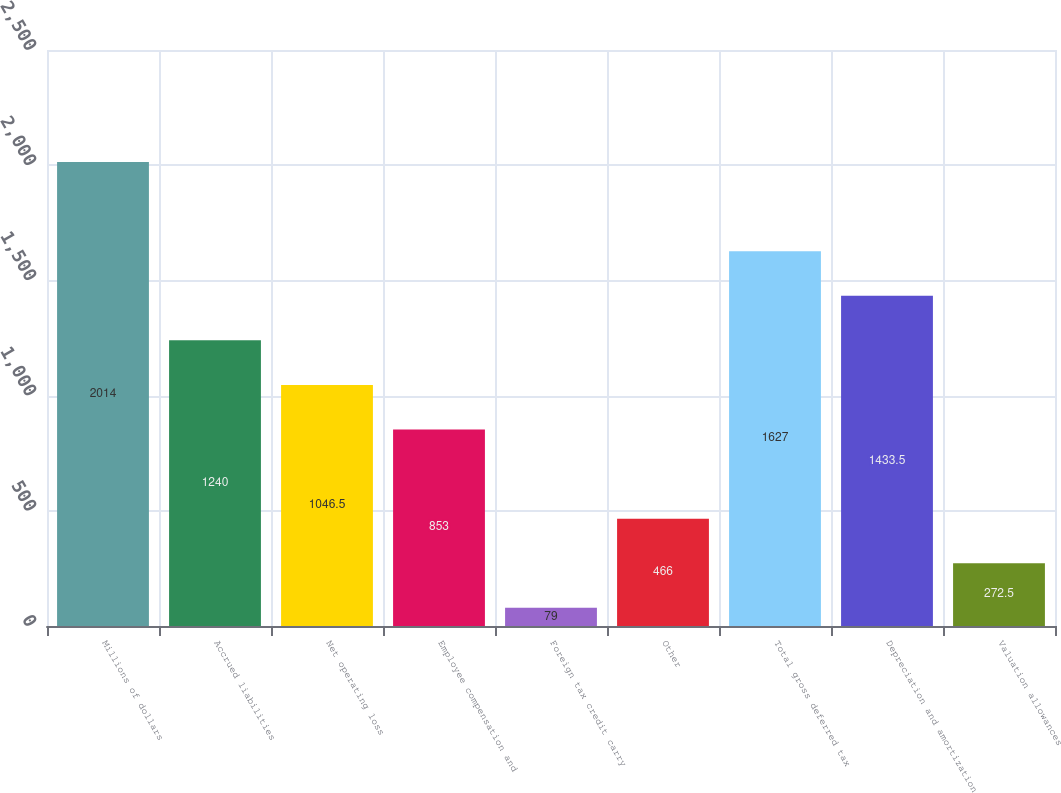Convert chart. <chart><loc_0><loc_0><loc_500><loc_500><bar_chart><fcel>Millions of dollars<fcel>Accrued liabilities<fcel>Net operating loss<fcel>Employee compensation and<fcel>Foreign tax credit carry<fcel>Other<fcel>Total gross deferred tax<fcel>Depreciation and amortization<fcel>Valuation allowances<nl><fcel>2014<fcel>1240<fcel>1046.5<fcel>853<fcel>79<fcel>466<fcel>1627<fcel>1433.5<fcel>272.5<nl></chart> 